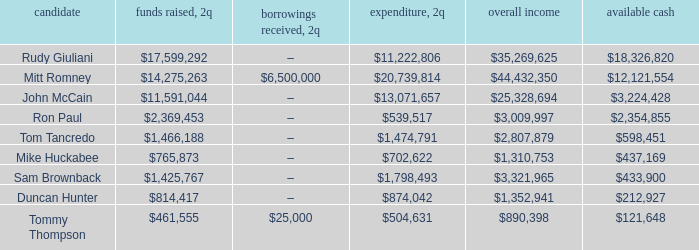Name the money spent for 2Q having candidate of john mccain $13,071,657. 